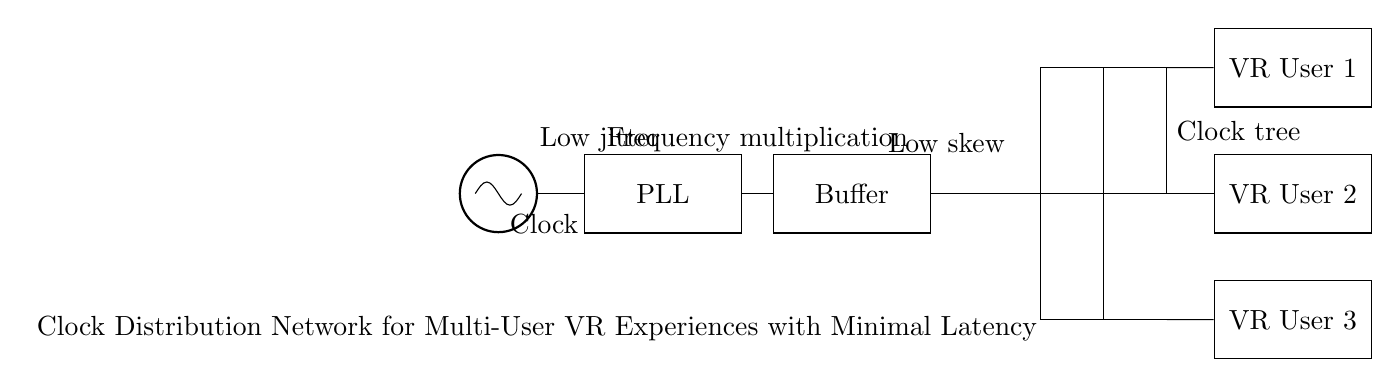What is the main component providing the clock signal in this circuit? The oscillator is clearly labeled as the clock source at the beginning of the circuit diagram. It is the first component and labeled as "Clock."
Answer: Clock What components are used for frequency manipulation in the circuit? The circuit includes a phase-locked loop (PLL) which is responsible for frequency multiplication, as indicated in the diagram with the label "PLL."
Answer: PLL How many VR users are included in this clock distribution network? There are three VR user components drawn in the circuit, each labeled as "VR User 1," "VR User 2," and "VR User 3." This is observable as each user is represented distinctly.
Answer: Three What is the purpose of the buffer in this circuit? The buffer is used to ensure low skew and drive the clock signal effectively to multiple outputs, as indicated by its label and the context of its connection in the circuit.
Answer: Low skew What type of network is depicted in the circuit diagram? The diagram is showing a clock distribution network that aims for minimizing latency based on its title at the bottom, indicating its strategic design for multi-user VR experiences.
Answer: Clock distribution network Which component is connected directly to the clock source? The PLL is directly connected to the clock source (oscillator), which clearly shows the path from the oscillator to the PLL in the diagram.
Answer: PLL 